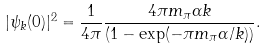<formula> <loc_0><loc_0><loc_500><loc_500>| \psi _ { k } ( 0 ) | ^ { 2 } = \frac { 1 } { 4 \pi } \frac { 4 \pi m _ { \pi } \alpha k } { \left ( 1 - \exp ( - \pi m _ { \pi } \alpha / k ) \right ) } .</formula> 